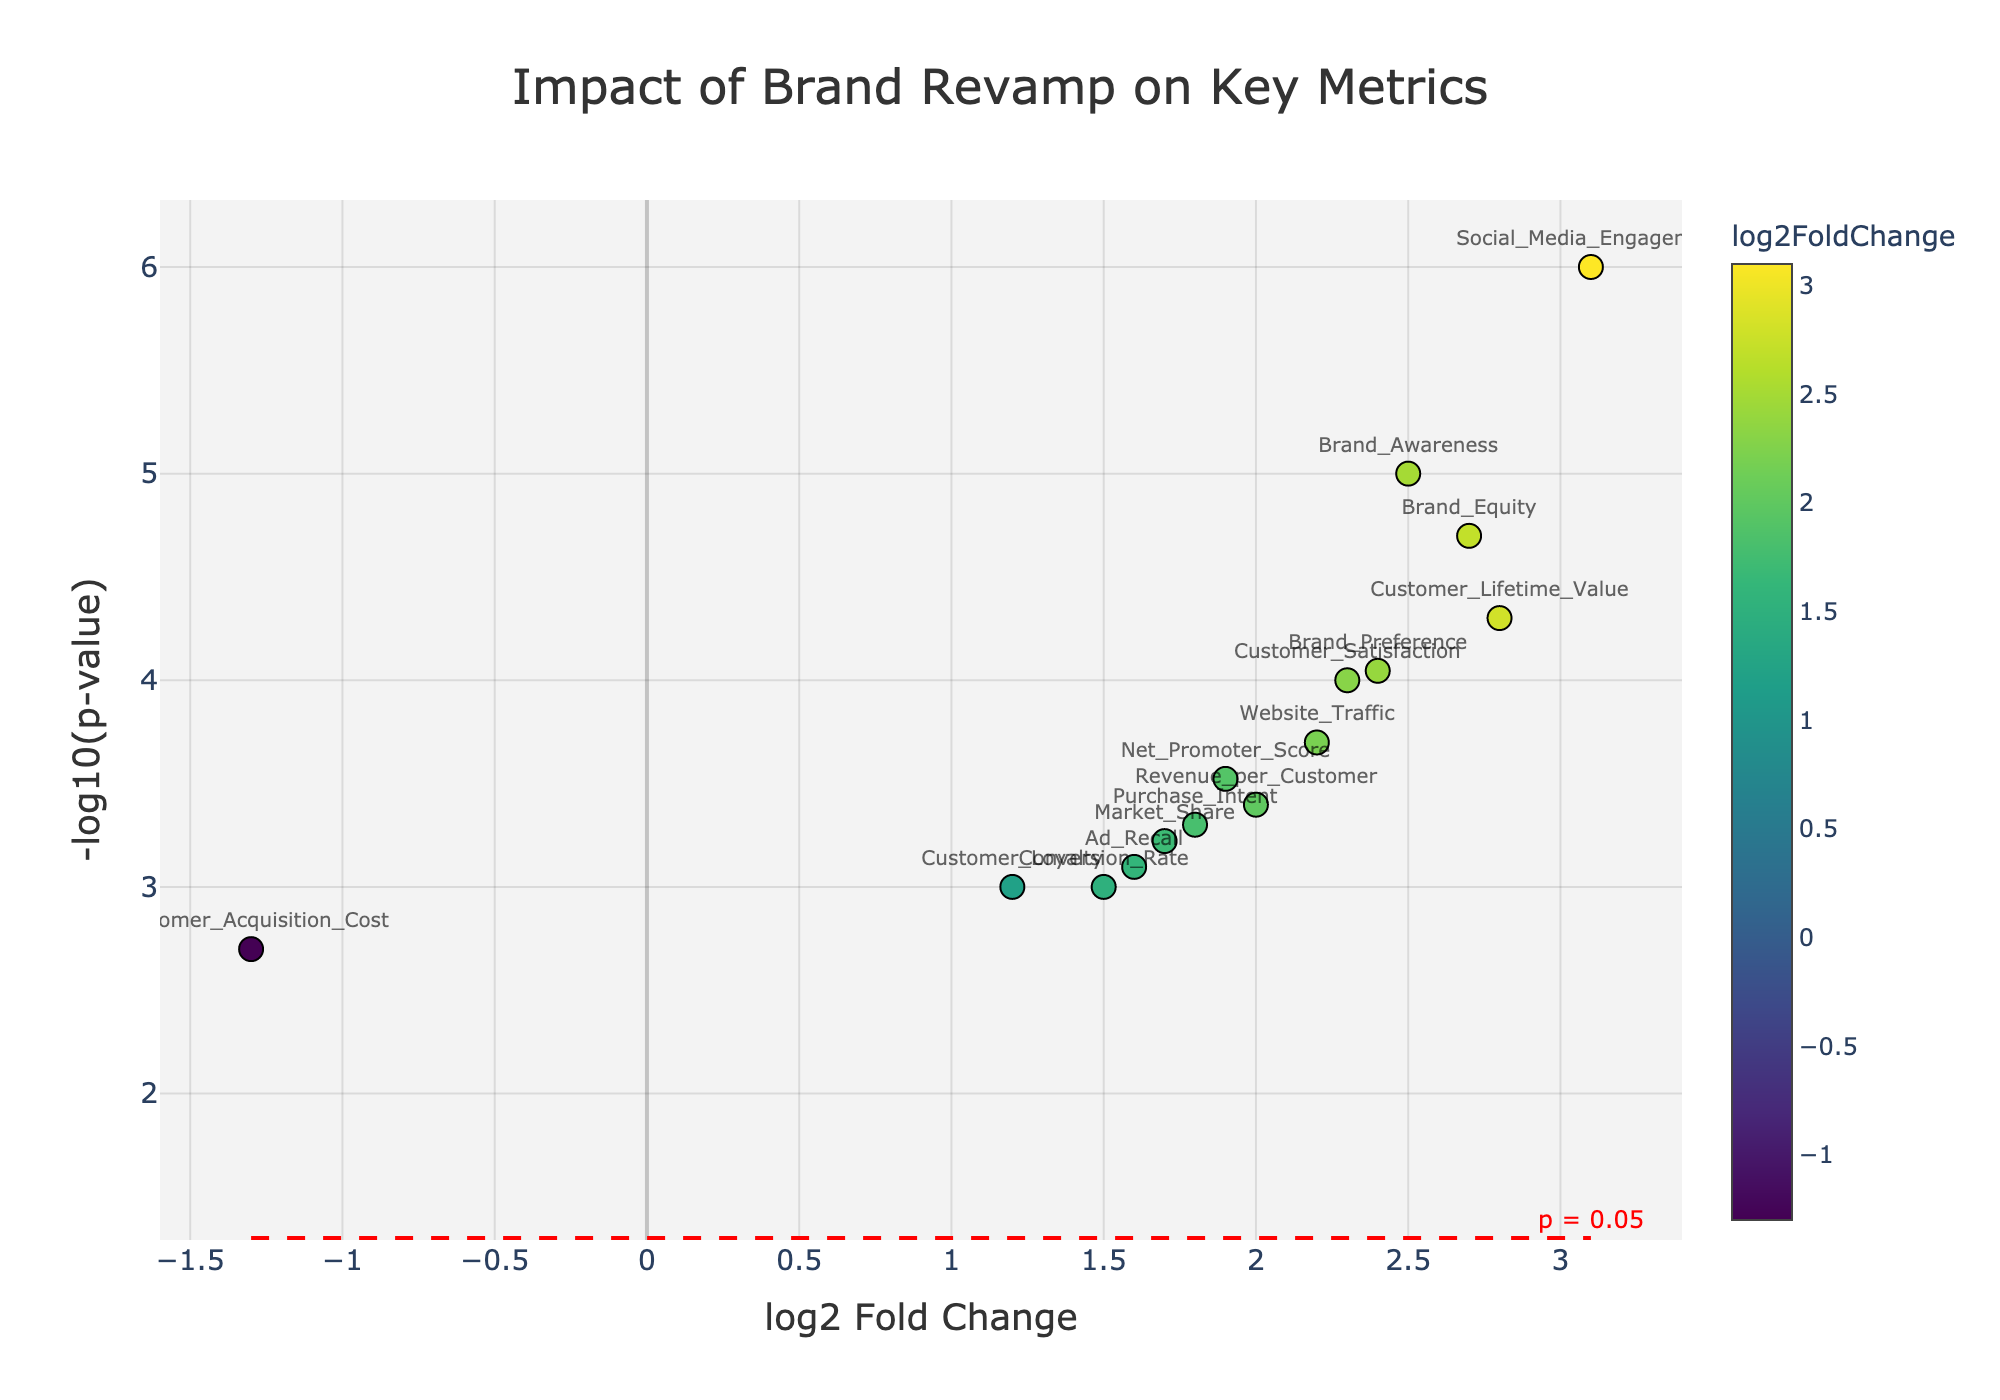What is the title of the plot? The title of a plot is usually found at the top and specifies the main subject of the visual representation. In this plot, the title states the main focus clearly.
Answer: Impact of Brand Revamp on Key Metrics How many data points are displayed on the plot? Each marker on the plot represents a data point corresponding to a specific gene, labeled with the gene name. By counting the unique markers, we find the total number of data points.
Answer: 14 Which metric has the highest log2 Fold Change? By comparing the x-axis values of the markers, the metric with the rightmost marker has the highest log2 Fold Change.
Answer: Social_Media_Engagement What is the significance threshold in terms of p-value? The plot has a red dashed line indicating the significance threshold on the y-axis, which corresponds to a specific p-value. In the annotation next to this line.
Answer: p = 0.05 Which two metrics have log2 Fold Changes close to 2.0? By looking at the markers near the x-axis value of 2.0 and their labels, we identify the metrics close to this value.
Answer: Brand_Equity, Revenue_per_Customer How many metrics show a significant change in engagement metrics? A metric is considered significant if it is above the red dashed line corresponding to a p-value of 0.05. By counting the markers above this line, we find the answer.
Answer: 11 Which metric has the lowest p-value and what is its log2 Fold Change? The metric with the highest y-axis value (representing -log10(p-value)) will have the lowest p-value. By checking the corresponding x-axis value, we identify its log2 Fold Change.
Answer: Social_Media_Engagement, 3.1 Which metrics have a negative log2 Fold Change, indicating a decrease in engagement? By looking at the markers on the left side of the y-axis origin (negative x-axis values), we identify metrics with negative log2 Fold Change.
Answer: Customer_Acquisition_Cost Compare Brand Awareness and Purchase Intent in terms of log2 Fold Change and p-value. Look at the position of these markers on both x and y axes to compare their log2 Fold Change and -log10(p-value). Brand Awareness has higher values in both metrics.
Answer: Brand Awareness: 2.5 (log2FC), <0.00001 (p-value); Purchase Intent: 1.8 (log2FC), 0.0005 (p-value) What is the approximate p-value for Customer Lifetime Value? To find the p-value by looking at the y-coordinate (-log10(p-value)) of the metric 'Customer Lifetime Value' and converting it back to p-value.
Answer: ~5.62e-05 